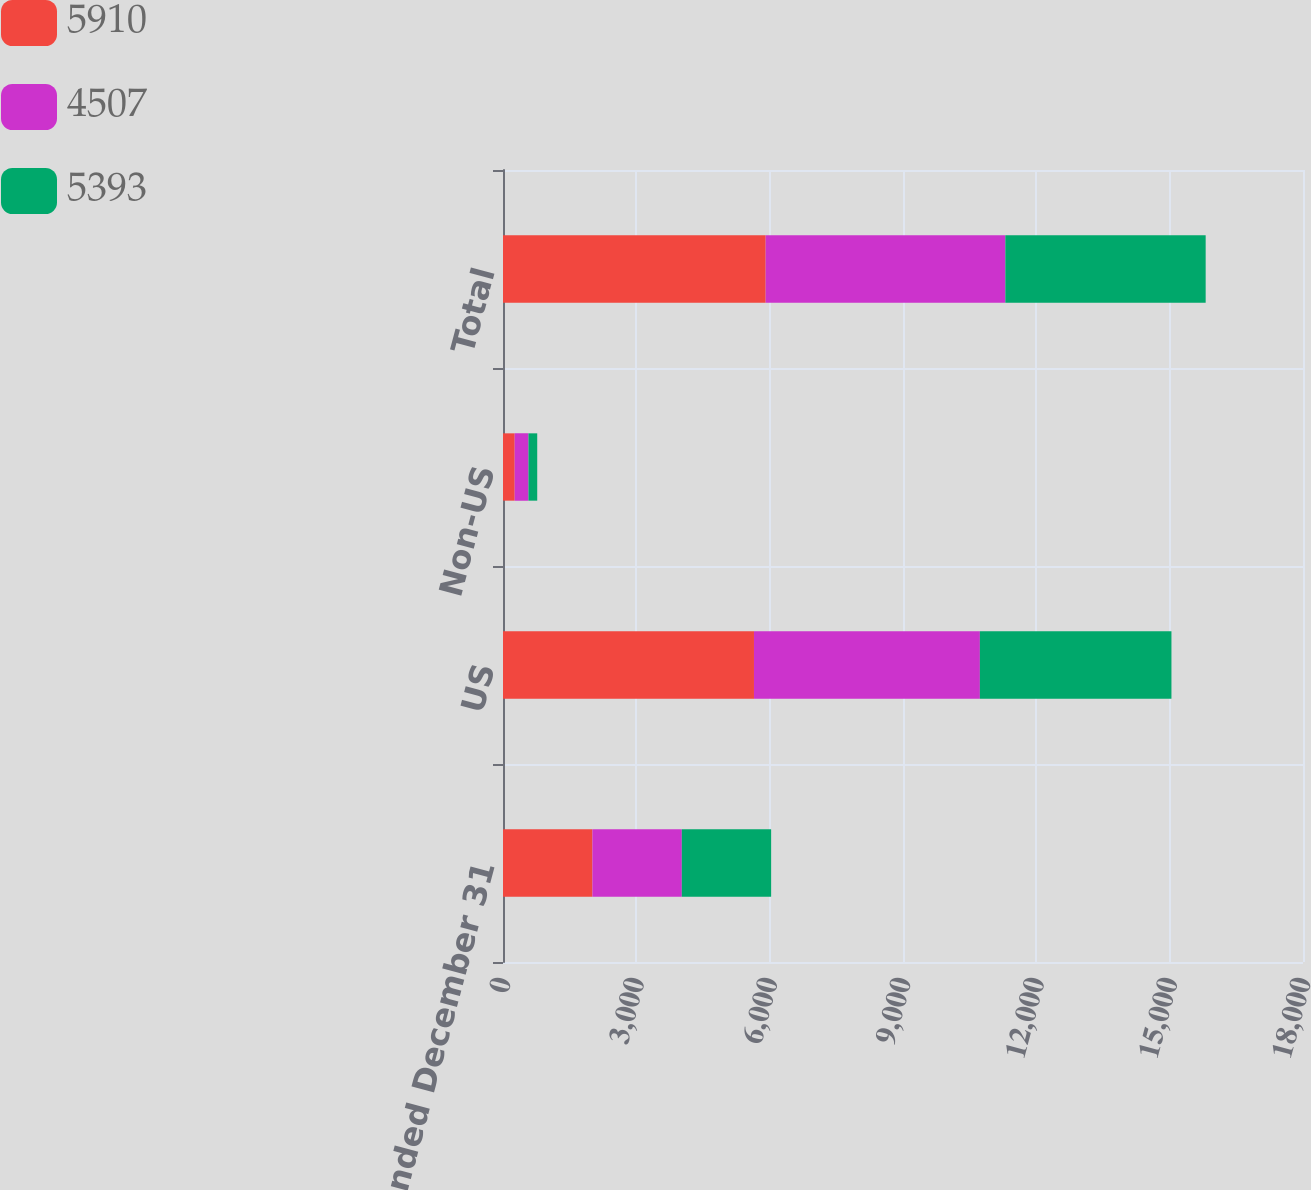<chart> <loc_0><loc_0><loc_500><loc_500><stacked_bar_chart><ecel><fcel>Years ended December 31<fcel>US<fcel>Non-US<fcel>Total<nl><fcel>5910<fcel>2012<fcel>5647<fcel>263<fcel>5910<nl><fcel>4507<fcel>2011<fcel>5083<fcel>310<fcel>5393<nl><fcel>5393<fcel>2010<fcel>4310<fcel>197<fcel>4507<nl></chart> 